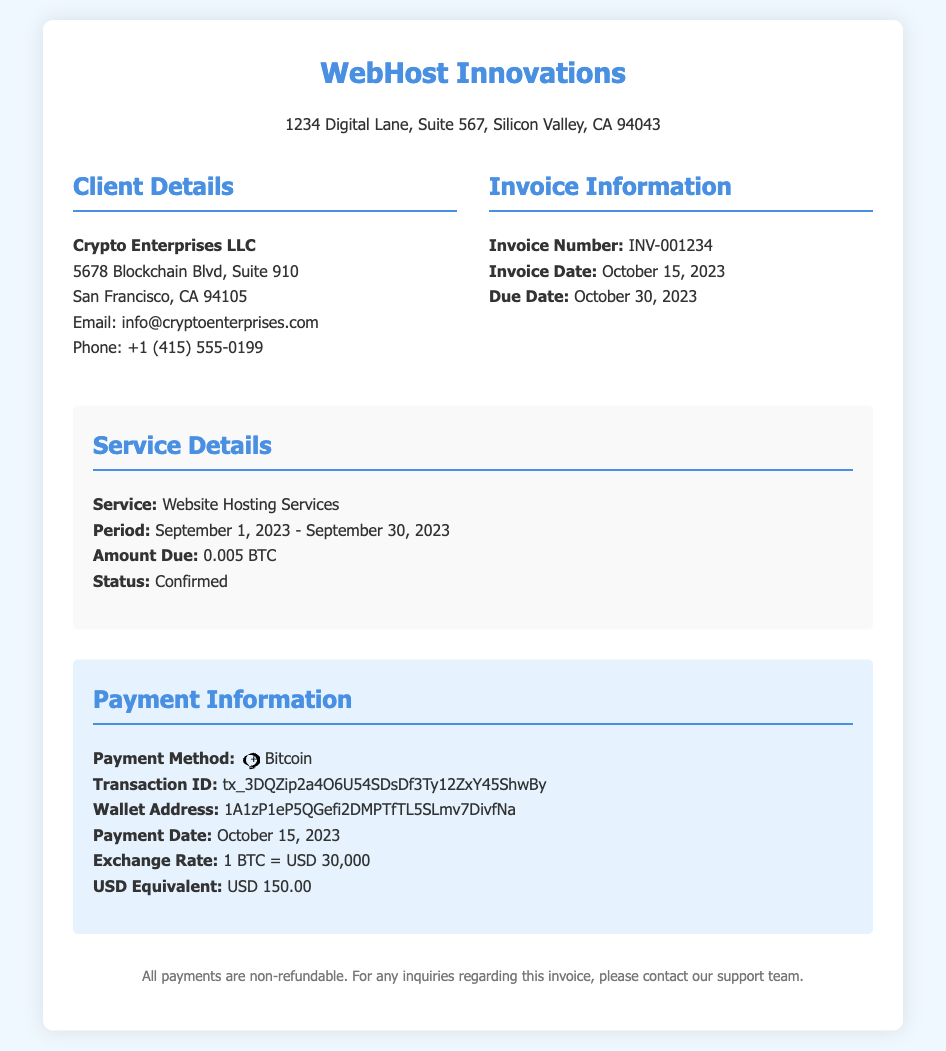What is the invoice number? The invoice number is specifically listed in the invoice details section.
Answer: INV-001234 What is the service period? The service period describes the timeframe for the website hosting services provided.
Answer: September 1, 2023 - September 30, 2023 Who is the client? The client details were provided in the invoice section, indicating the name of the client.
Answer: Crypto Enterprises LLC What is the amount due in Bitcoin? The amount due is specified in the service details section.
Answer: 0.005 BTC What is the payment date? The payment date is mentioned in the payment information section of the document.
Answer: October 15, 2023 What is the USD equivalent of the payment? This information is provided in the payment information section as the monetary equivalent of the Bitcoin paid.
Answer: USD 150.00 What is the payment method used? The payment method details can be found in the payment information section of the invoice.
Answer: Bitcoin What is the due date for the invoice? The due date is clearly stated in the invoice information section.
Answer: October 30, 2023 What is the exchange rate mentioned? The exchange rate is a critical piece of information related to the monetary transaction and is listed accordingly.
Answer: 1 BTC = USD 30,000 